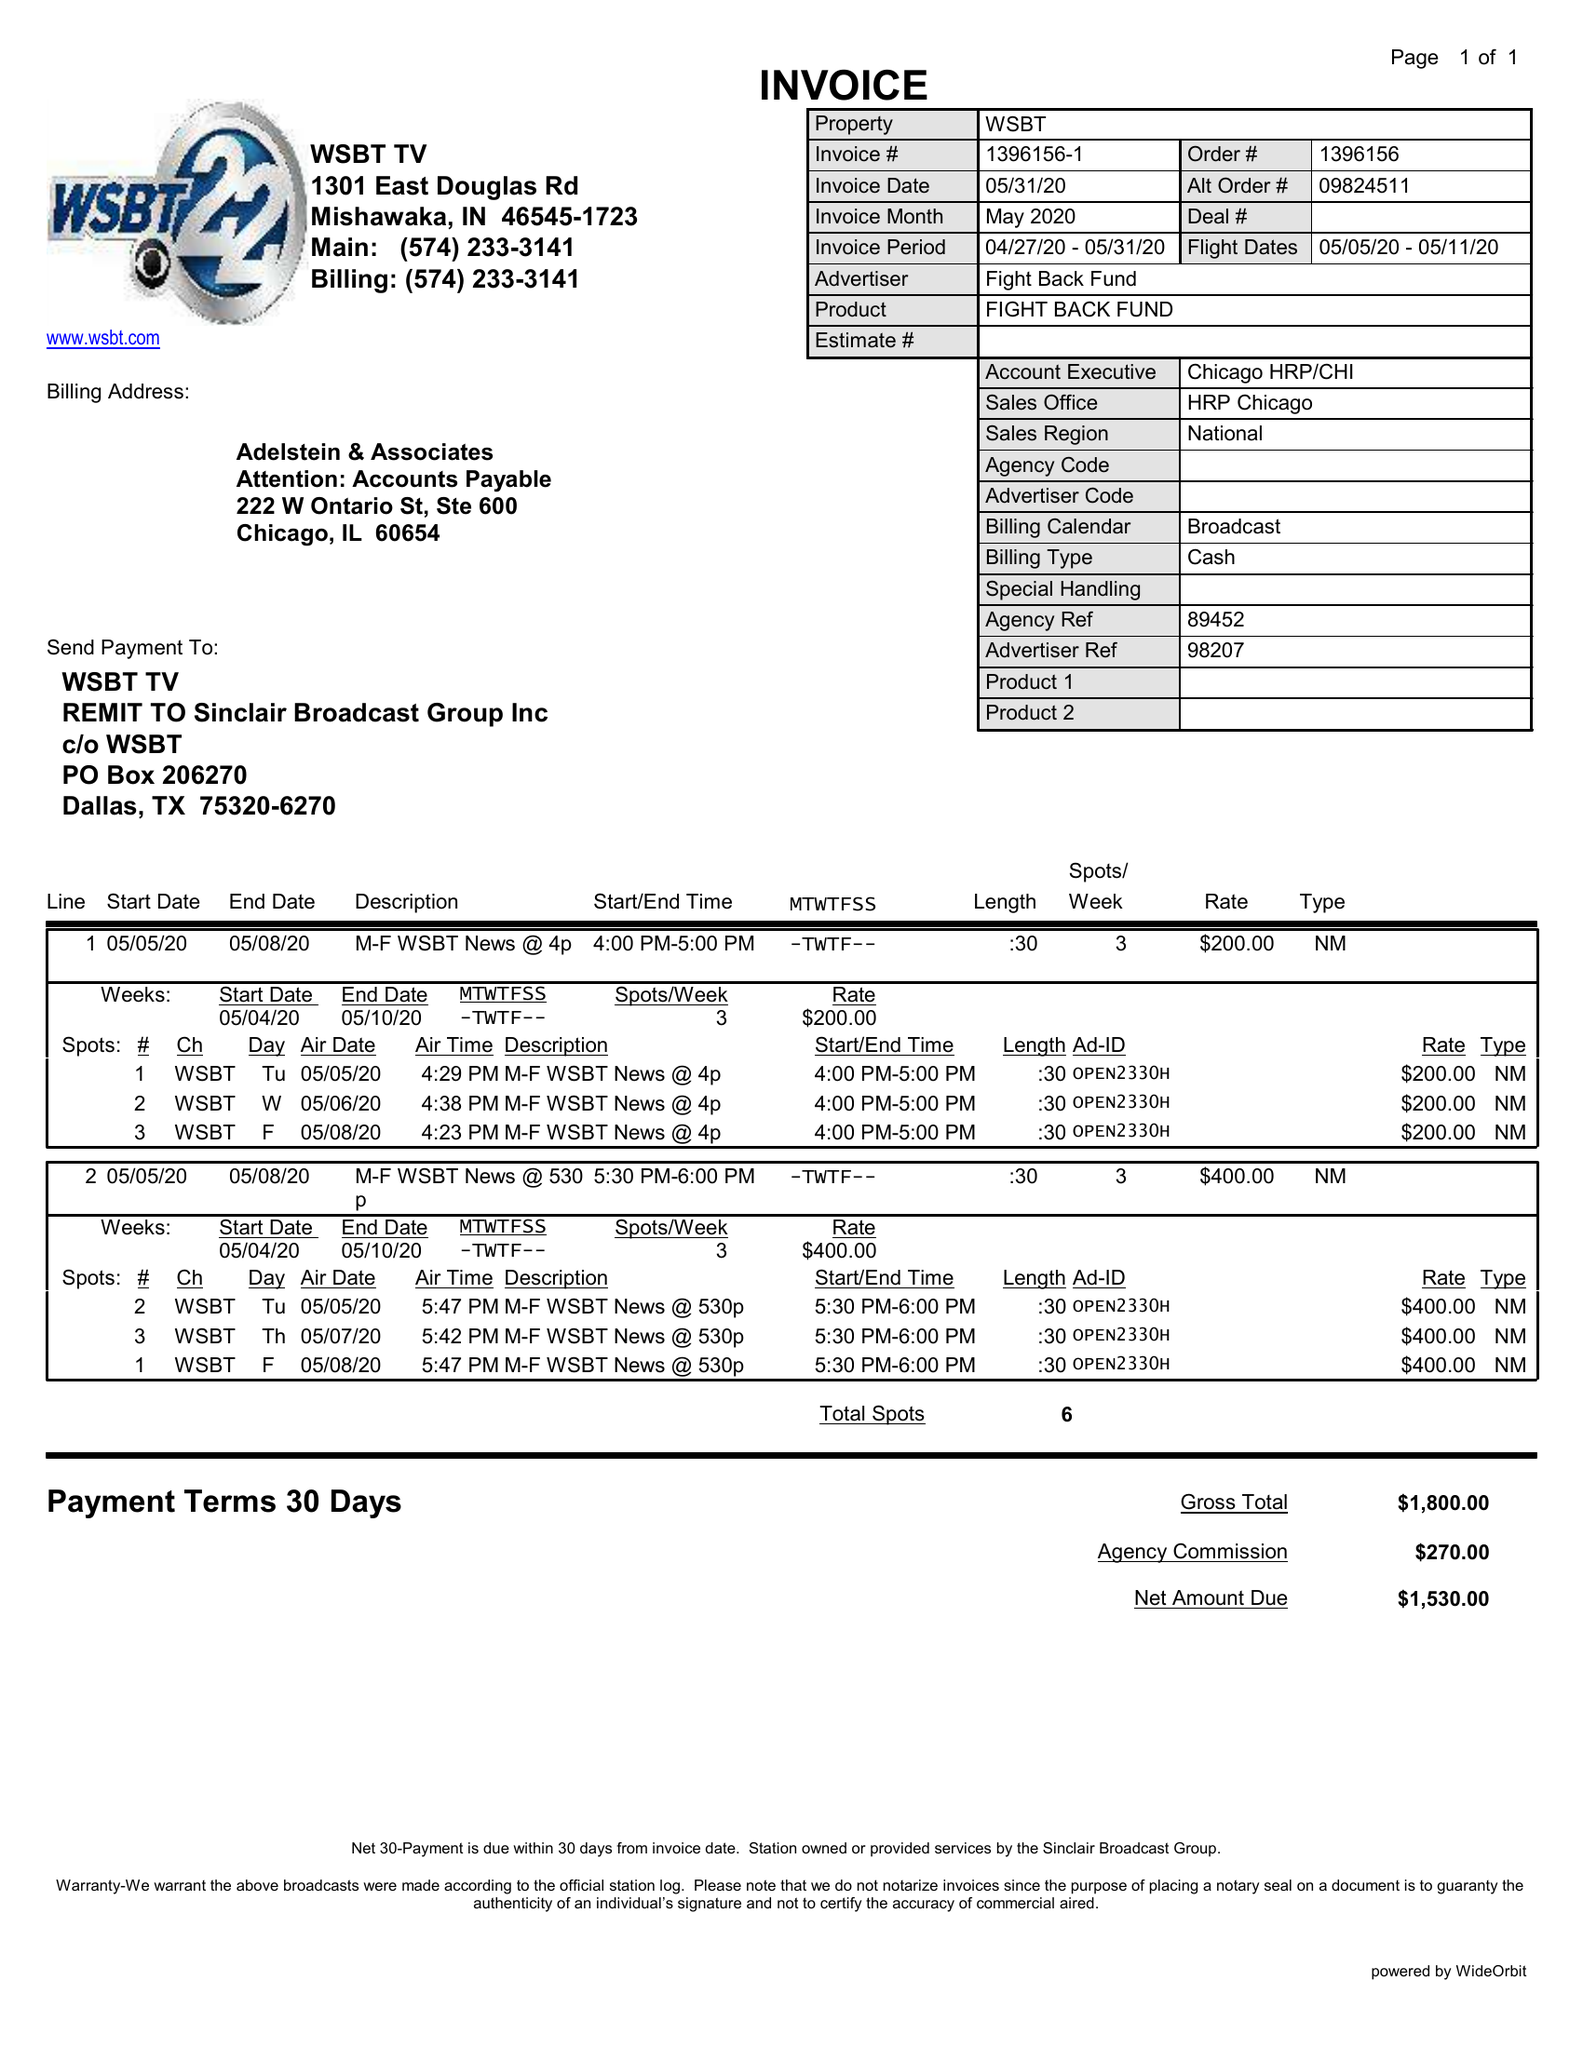What is the value for the contract_num?
Answer the question using a single word or phrase. 1396156 